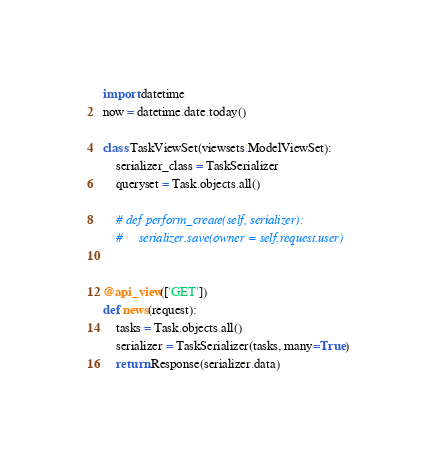<code> <loc_0><loc_0><loc_500><loc_500><_Python_>
import datetime
now = datetime.date.today()

class TaskViewSet(viewsets.ModelViewSet):
    serializer_class = TaskSerializer
    queryset = Task.objects.all()

    # def perform_create(self, serializer):
    #     serializer.save(owner = self.request.user)


@api_view(['GET'])
def news(request):
    tasks = Task.objects.all()
    serializer = TaskSerializer(tasks, many=True)
    return Response(serializer.data)
</code> 